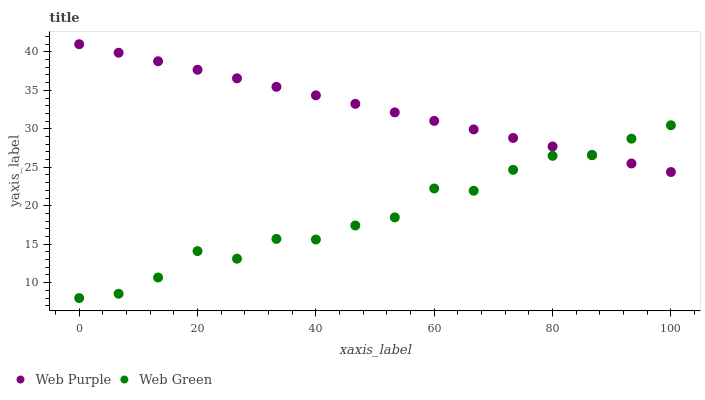Does Web Green have the minimum area under the curve?
Answer yes or no. Yes. Does Web Purple have the maximum area under the curve?
Answer yes or no. Yes. Does Web Green have the maximum area under the curve?
Answer yes or no. No. Is Web Purple the smoothest?
Answer yes or no. Yes. Is Web Green the roughest?
Answer yes or no. Yes. Is Web Green the smoothest?
Answer yes or no. No. Does Web Green have the lowest value?
Answer yes or no. Yes. Does Web Purple have the highest value?
Answer yes or no. Yes. Does Web Green have the highest value?
Answer yes or no. No. Does Web Green intersect Web Purple?
Answer yes or no. Yes. Is Web Green less than Web Purple?
Answer yes or no. No. Is Web Green greater than Web Purple?
Answer yes or no. No. 